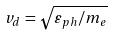Convert formula to latex. <formula><loc_0><loc_0><loc_500><loc_500>v _ { d } = \sqrt { \varepsilon _ { p h } / m _ { e } }</formula> 